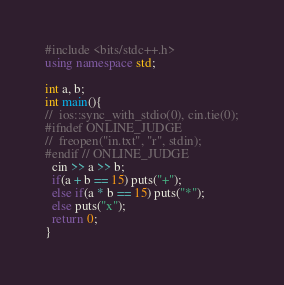Convert code to text. <code><loc_0><loc_0><loc_500><loc_500><_C++_>#include <bits/stdc++.h>
using namespace std;

int a, b;
int main(){
//  ios::sync_with_stdio(0), cin.tie(0);
#ifndef ONLINE_JUDGE
//  freopen("in.txt", "r", stdin);
#endif // ONLINE_JUDGE
  cin >> a >> b;
  if(a + b == 15) puts("+");
  else if(a * b == 15) puts("*");
  else puts("x");
  return 0;
}
</code> 